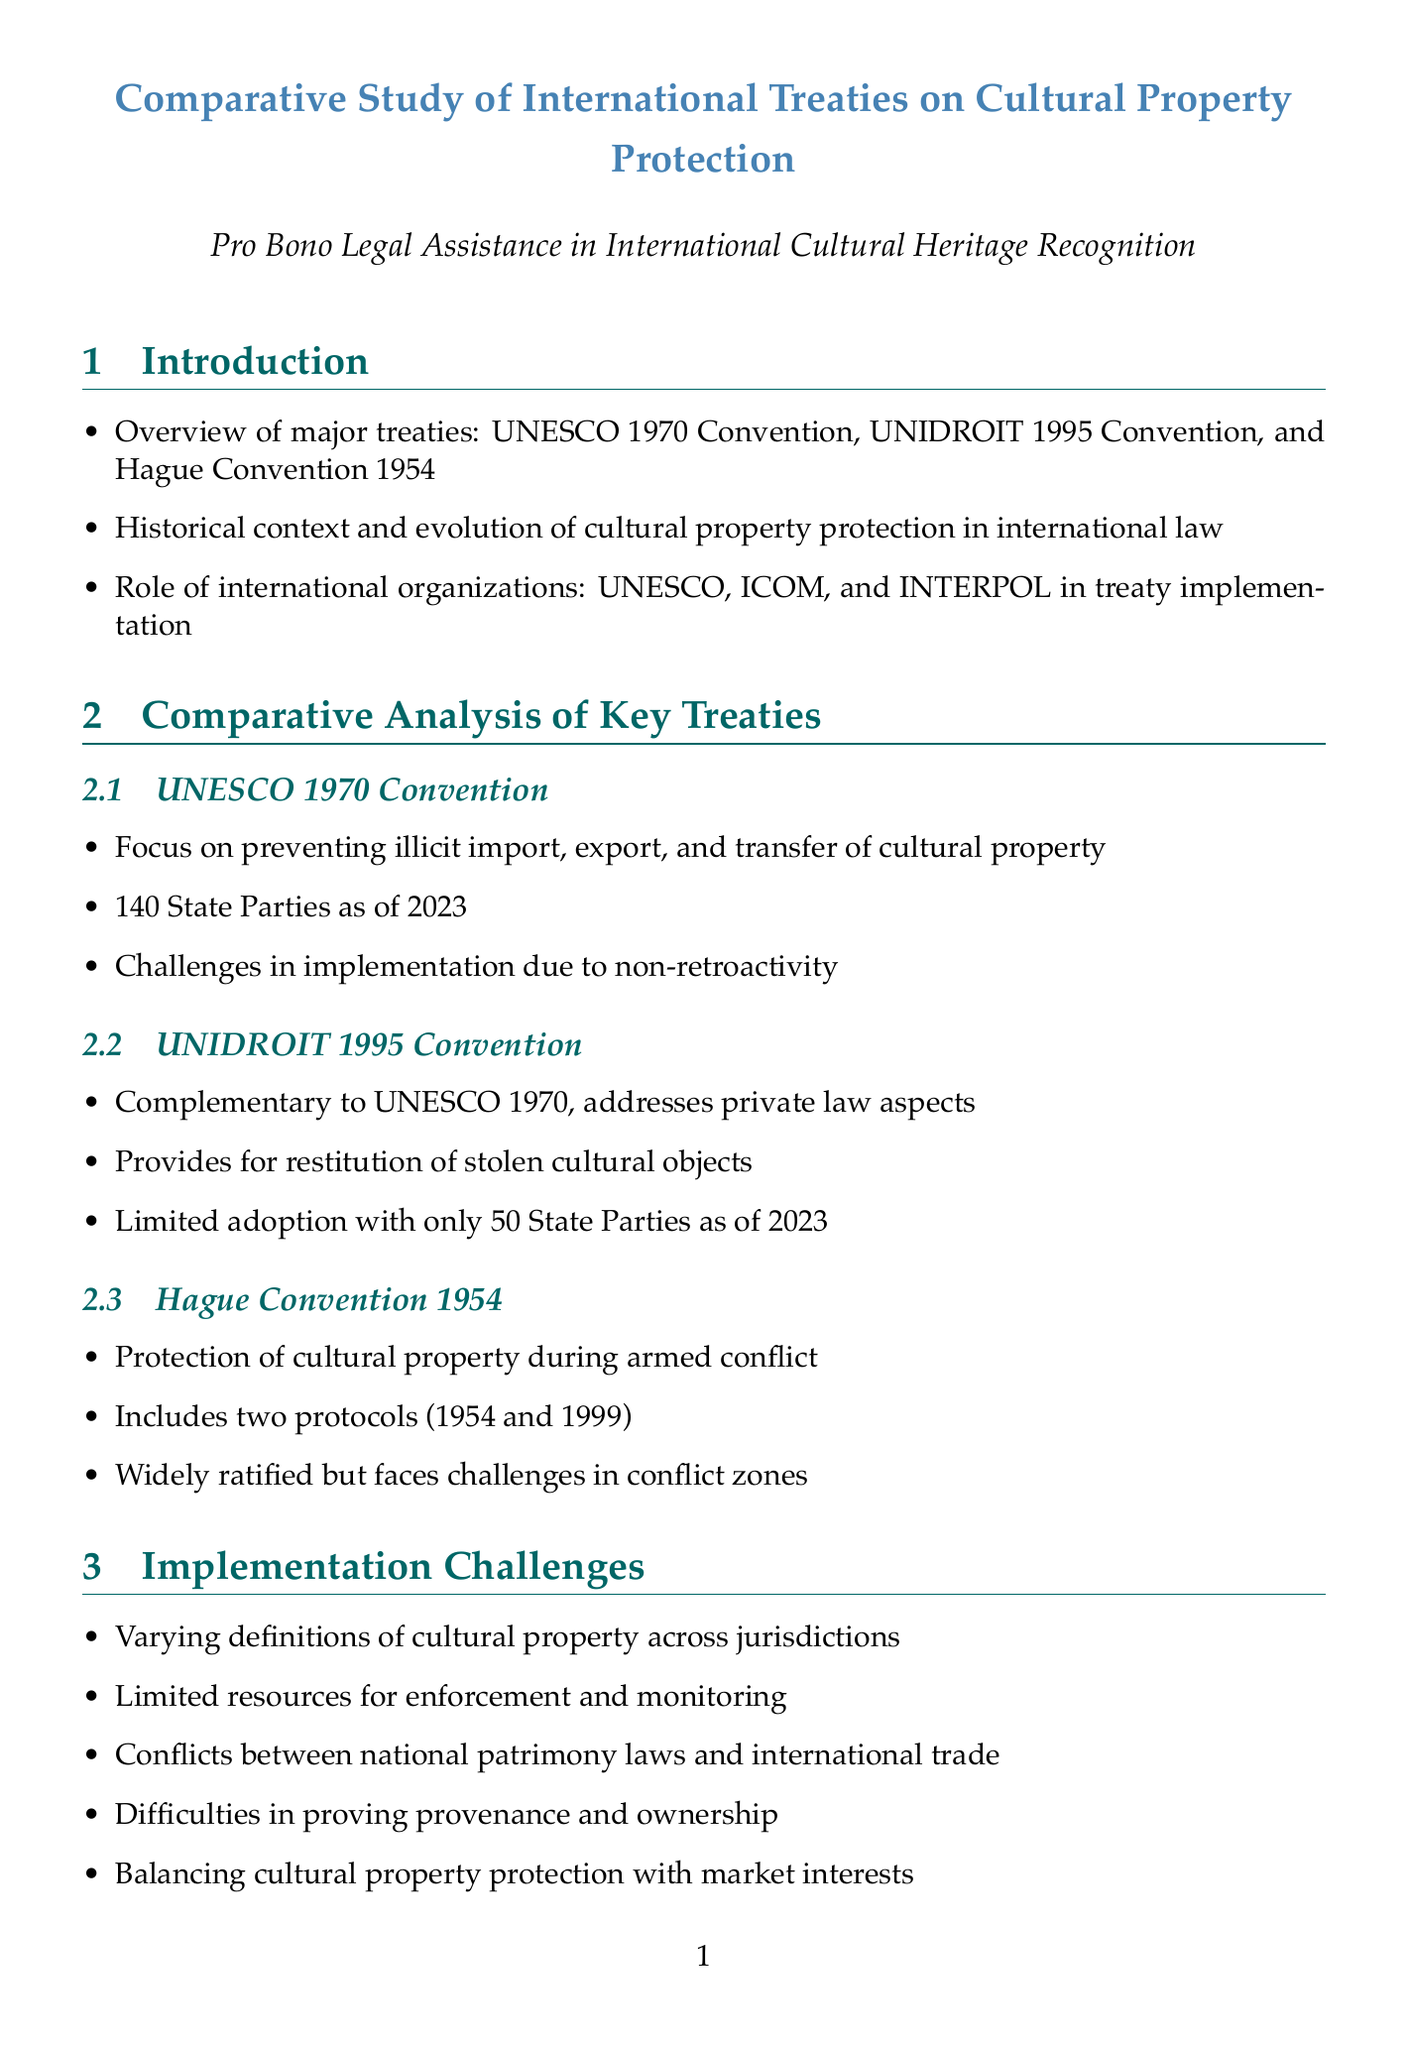What is the primary focus of the UNESCO 1970 Convention? The UNESCO 1970 Convention focuses on preventing illicit import, export, and transfer of cultural property.
Answer: Preventing illicit import, export, and transfer of cultural property How many State Parties are part of the UNIDROIT 1995 Convention as of 2023? The document states that there are only 50 State Parties as of 2023 under the UNIDROIT 1995 Convention.
Answer: 50 What year was the Italy-United States Bilateral Agreement signed? According to the report, the Memorandum of Understanding was signed in 2001.
Answer: 2001 Which international organization was involved in the designation of Cambodia's Temple of Preah Vihear as a World Heritage Site? The document mentions that UNESCO designated Cambodia's Temple of Preah Vihear as a World Heritage Site.
Answer: UNESCO What is a major implementation challenge mentioned in the report? The varying definitions of cultural property across jurisdictions is listed as a challenge in implementation.
Answer: Varying definitions of cultural property across jurisdictions What is one recommendation for future directions in cultural property protection? The report suggests harmonization of national laws with international treaty obligations as a future direction.
Answer: Harmonization of national laws with international treaty obligations Name one of the key stakeholders in cultural property protection. The document lists several stakeholders, including UNESCO, which is a key stakeholder.
Answer: UNESCO What does the UNIDROIT 1995 Convention provide for? The document states that the UNIDROIT 1995 Convention provides for restitution of stolen cultural objects.
Answer: Restitution of stolen cultural objects How many protocols are included in the Hague Convention 1954? The report specifies that the Hague Convention includes two protocols (1954 and 1999).
Answer: Two protocols 